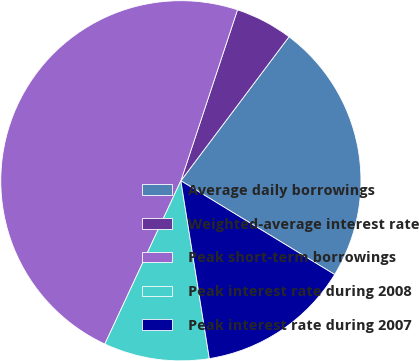<chart> <loc_0><loc_0><loc_500><loc_500><pie_chart><fcel>Average daily borrowings<fcel>Weighted-average interest rate<fcel>Peak short-term borrowings<fcel>Peak interest rate during 2008<fcel>Peak interest rate during 2007<nl><fcel>23.46%<fcel>5.16%<fcel>48.15%<fcel>9.46%<fcel>13.76%<nl></chart> 